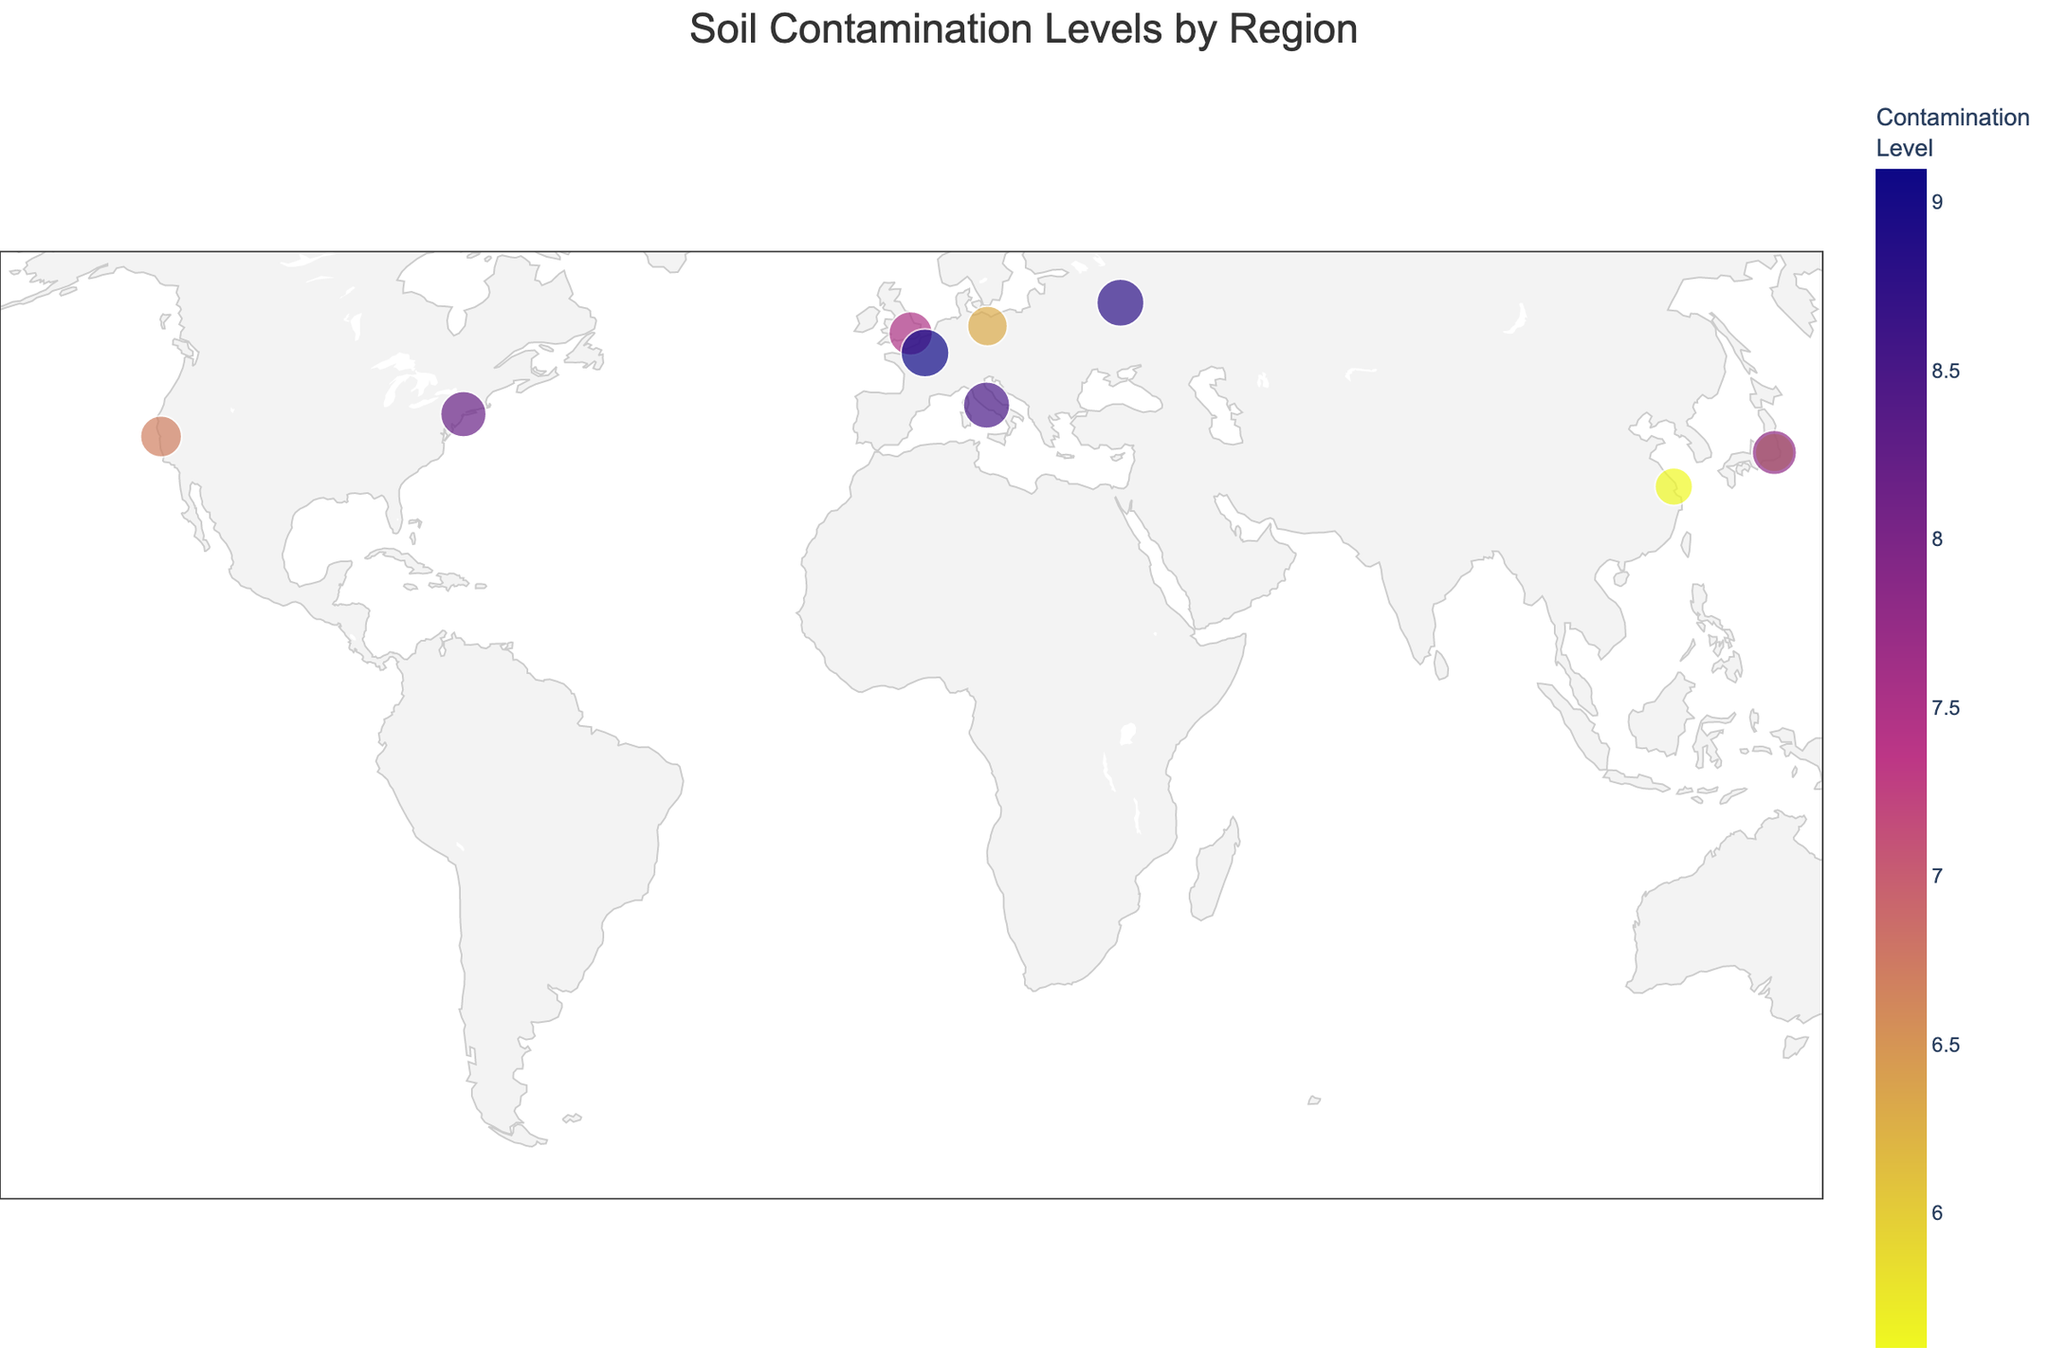What is the title of the figure? The title is usually found at the top of the figure, suggesting its main focus. In this case, it reads "Soil Contamination Levels by Region."
Answer: Soil Contamination Levels by Region Which region has the highest contamination level? By examining the color intensity and size of the markers in the figure, the Southern Coastal region shows the highest contamination level, marked at 9.1.
Answer: Southern Coastal What contaminant source is linked to the Hudson Valley region? The figure's hover information provides details about each region. For Hudson Valley, it mentions "Industrial Runoff" as the contaminant source.
Answer: Industrial Runoff How many regions have contamination levels higher than 8.0? To determine this, count the regions with markers showing contamination levels above 8.0: Hudson Valley, Northern Prairies, Southeastern Basin, and Southern Coastal.
Answer: Four regions Compare the contamination levels in Central Valley and Coastal Plains. Which one is higher? By comparing the markers' color intensity and size, Central Valley has a contamination level of 6.7, while Coastal Plains has a level of 5.6. Central Valley is higher.
Answer: Central Valley What are the contaminants affecting Western Valleys and Midwest Plains? The hover information reveals that Western Valleys deal with Pathogens (from Sewage Sludge), whereas Midwest Plains deal with PAHs (from Urban Expansion).
Answer: Pathogens and PAHs Identify the region with the lowest contamination level and state the contaminant type. By examining the marker with the least intensity, Coastal Plains have the lowest contamination level at 5.6, with Mercury as the contaminant type.
Answer: Coastal Plains, Mercury Which regions are affected by agricultural runoff and what are their contamination levels? Checking the markers for contaminant sources, Southern Coastal is affected by Agricultural Runoff with a contamination level of 9.1.
Answer: Southern Coastal, 9.1 What is the average contamination level of all regions shown on the map? Sum all contamination levels (8.2 + 6.7 + 5.9 + 7.5 + 9.1 + 8.8 + 6.3 + 7.8 + 8.5 + 5.6) = 74.4, then divide by the number of regions, which is 10. The average is 74.4 / 10 = 7.44
Answer: 7.44 What is the most common contaminant source across the regions? By counting the occurrences of each contaminant source in the hover information, we identify that there is no repeat, each source occurs only once.
Answer: None 